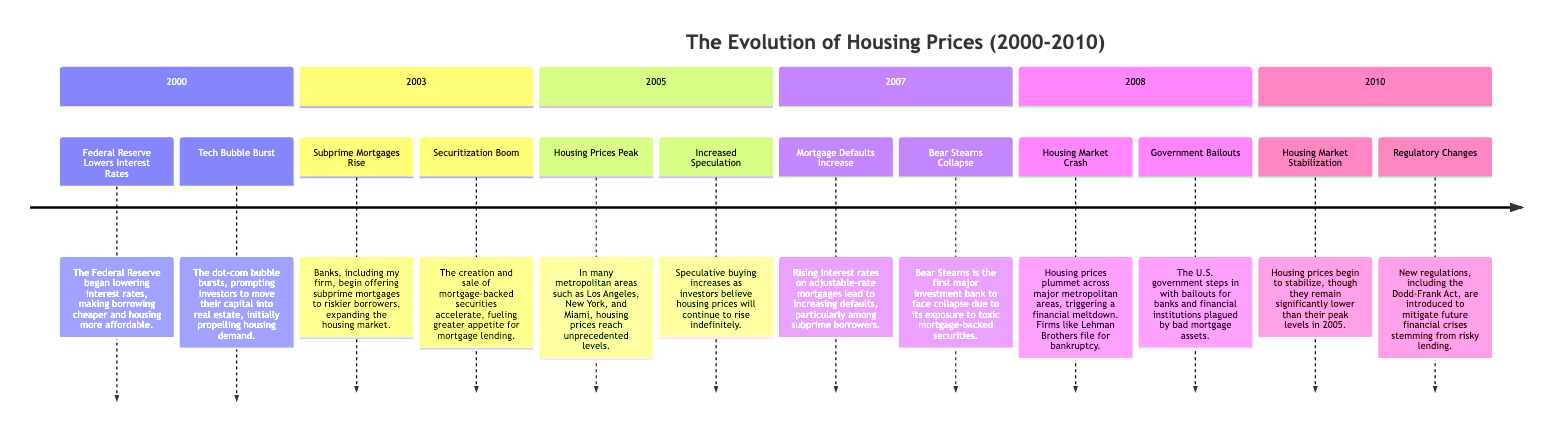What event initiated the rise of subprime mortgages? The event that initiated the rise of subprime mortgages is when banks began offering them to riskier borrowers in 2003. This event is clearly marked in the timeline for the year 2003.
Answer: Subprime Mortgages Rise What major investment bank collapsed in 2007? The major investment bank that collapsed in 2007 is Bear Stearns, as specified in the timeline for that year.
Answer: Bear Stearns In which year did housing prices peak across major metropolitan areas? Housing prices peaked in 2005, as indicated in the timeline for that year. The event is specifically mentioned as "Housing Prices Peak."
Answer: 2005 What was the notable government action taken in 2008? The notable government action taken in 2008 was the implementation of bailouts for banks and financial institutions, as detailed in the timeline that year.
Answer: Government Bailouts What trend in housing prices began in 2010? The trend that began in 2010 is the stabilization of housing prices, although they remained significantly lower than their peak levels in 2005. This is indicated in the timeline for that year.
Answer: Housing Market Stabilization Which event caused mortgage defaults to increase in 2007? The event that caused mortgage defaults to increase in 2007 was rising interest rates on adjustable-rate mortgages. This is highlighted in the timeline for that year.
Answer: Rising interest rates How many major events are listed for the year 2008? The year 2008 lists two major events: the Housing Market Crash and Government Bailouts. To determine this, one simply counts the events listed under the 2008 section of the timeline.
Answer: 2 What was a consequence of the tech bubble burst in 2000? A consequence of the tech bubble burst in 2000 was that investors moved their capital into real estate, initially boosting housing demand. This is explicitly noted in the timeline for that year.
Answer: Increased housing demand Which regulatory changes were introduced in 2010? The regulatory changes introduced in 2010 include the Dodd-Frank Act, which aimed at mitigating future financial crises stemming from risky lending practices. This is mentioned in the timeline for 2010.
Answer: Dodd-Frank Act 